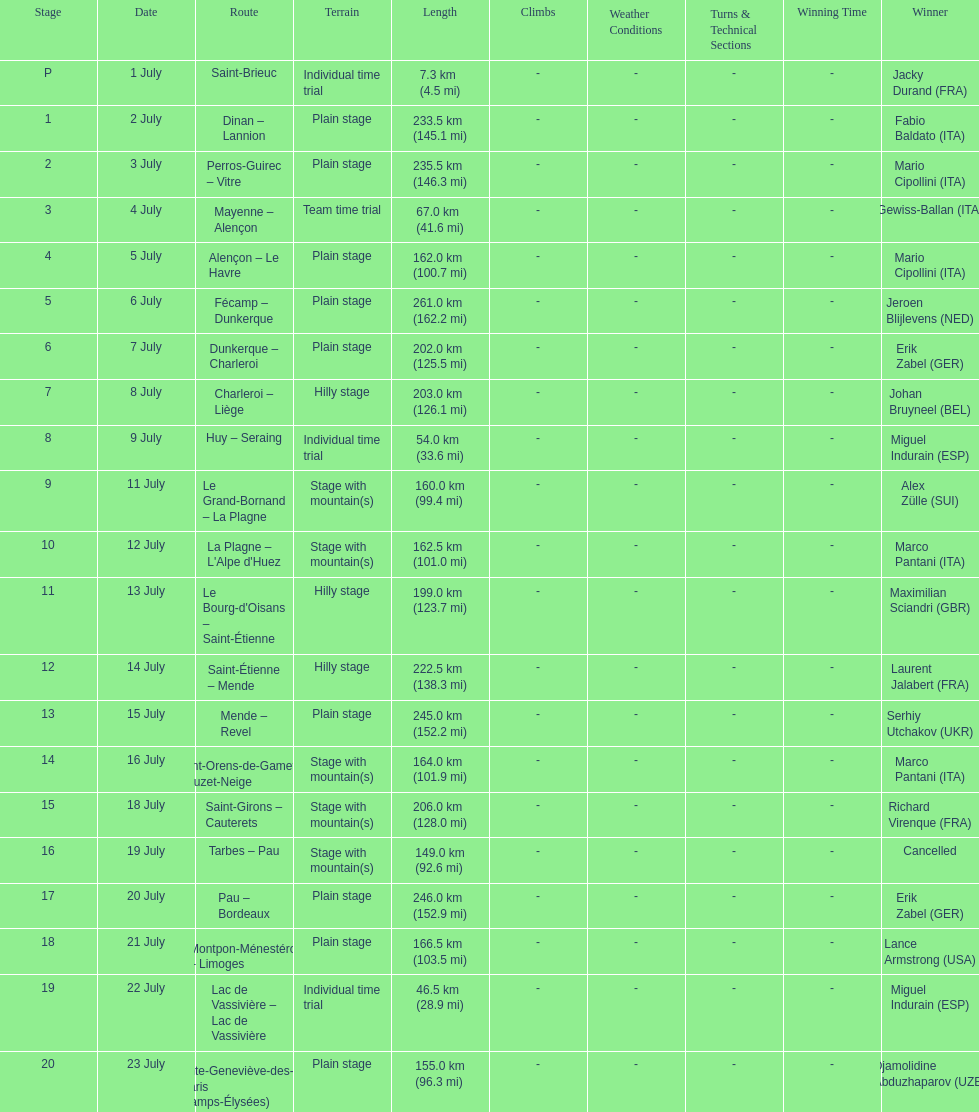How many consecutive km were raced on july 8th? 203.0 km (126.1 mi). 